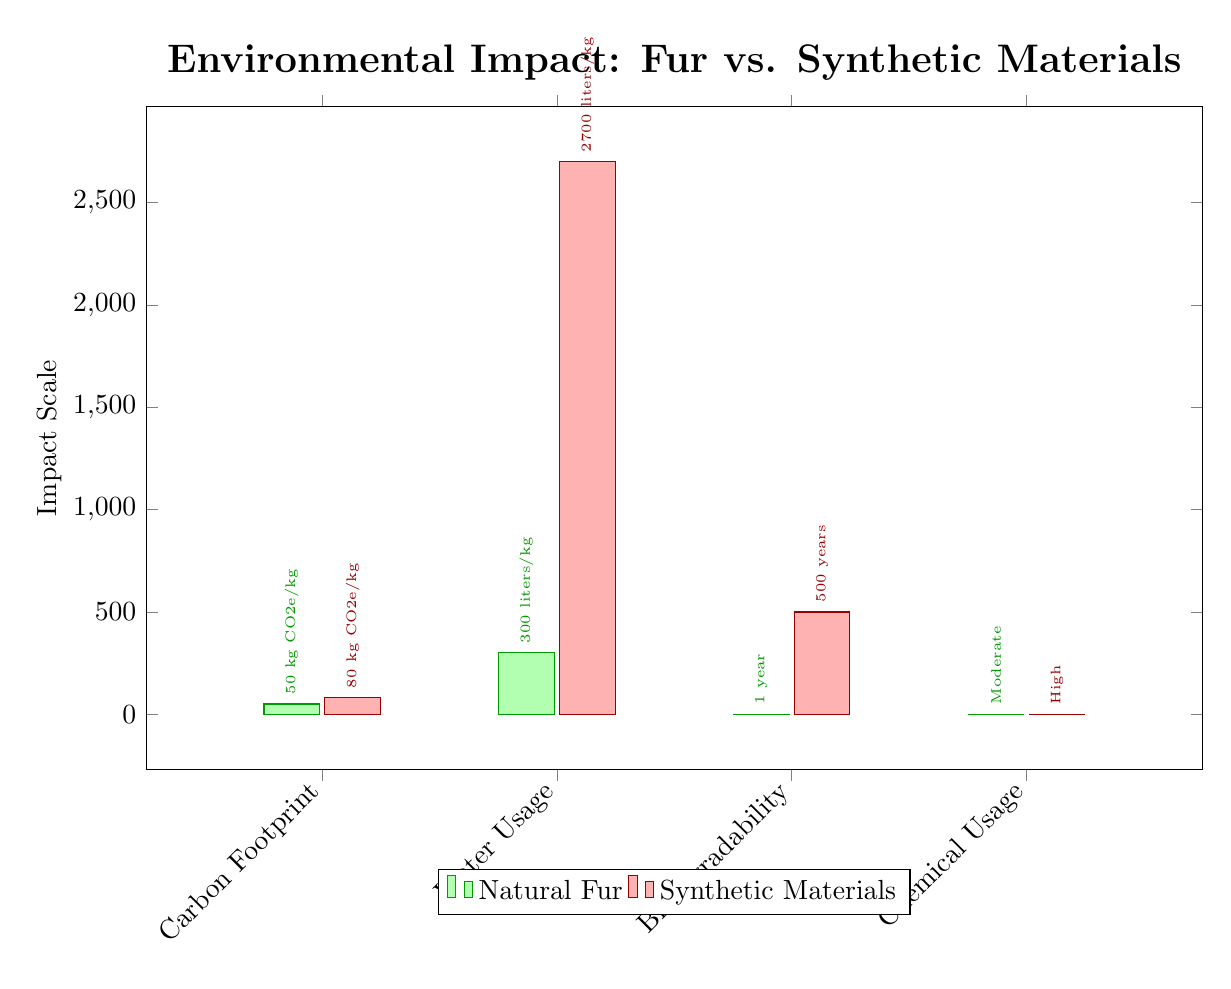What is the carbon footprint of synthetic materials? Referring to the carbon footprint value in the diagram, synthetic materials show a measurement of 80 kg CO2e/kg.
Answer: 80 kg CO2e/kg Which has a lower water usage, fur or synthetic materials? By comparing the water usage values in the diagram, fur has a usage of 300 liters/kg while synthetic materials have 2700 liters/kg. Therefore, fur has lower water usage.
Answer: Fur What is the biodegradability duration of natural fur? Looking at the biodegradability measurement for natural fur in the diagram, it indicates a duration of 1 year.
Answer: 1 year How many impact categories are shown in the diagram? The diagram displays four categories: carbon footprint, water usage, biodegradability, and chemical usage. Thus, there are four impact categories.
Answer: 4 Which material has a higher level of chemical usage? Upon examining the chemical usage values, synthetic materials have a rating of 1 (high) compared to fur, which has a rating of 0.5 (moderate). Therefore, synthetic materials have a higher chemical usage level.
Answer: Synthetic materials What is the water usage for natural fur? The water usage for natural fur is explicitly shown in the diagram as 300 liters/kg.
Answer: 300 liters/kg Which impact dimension shows the most significant difference between fur and synthetic materials? By analyzing the values, chemical usage has close but distinguishable scores of 0.5 for fur and 1 for synthetic materials, showcasing a notable difference, but the most significant difference lies in the water usage category, with a difference of 2400 liters/kg (300 vs. 2700).
Answer: Water usage What is the biodegradability duration for synthetic materials? The diagram indicates that synthetic materials have a biodegradability duration of 500 years.
Answer: 500 years 